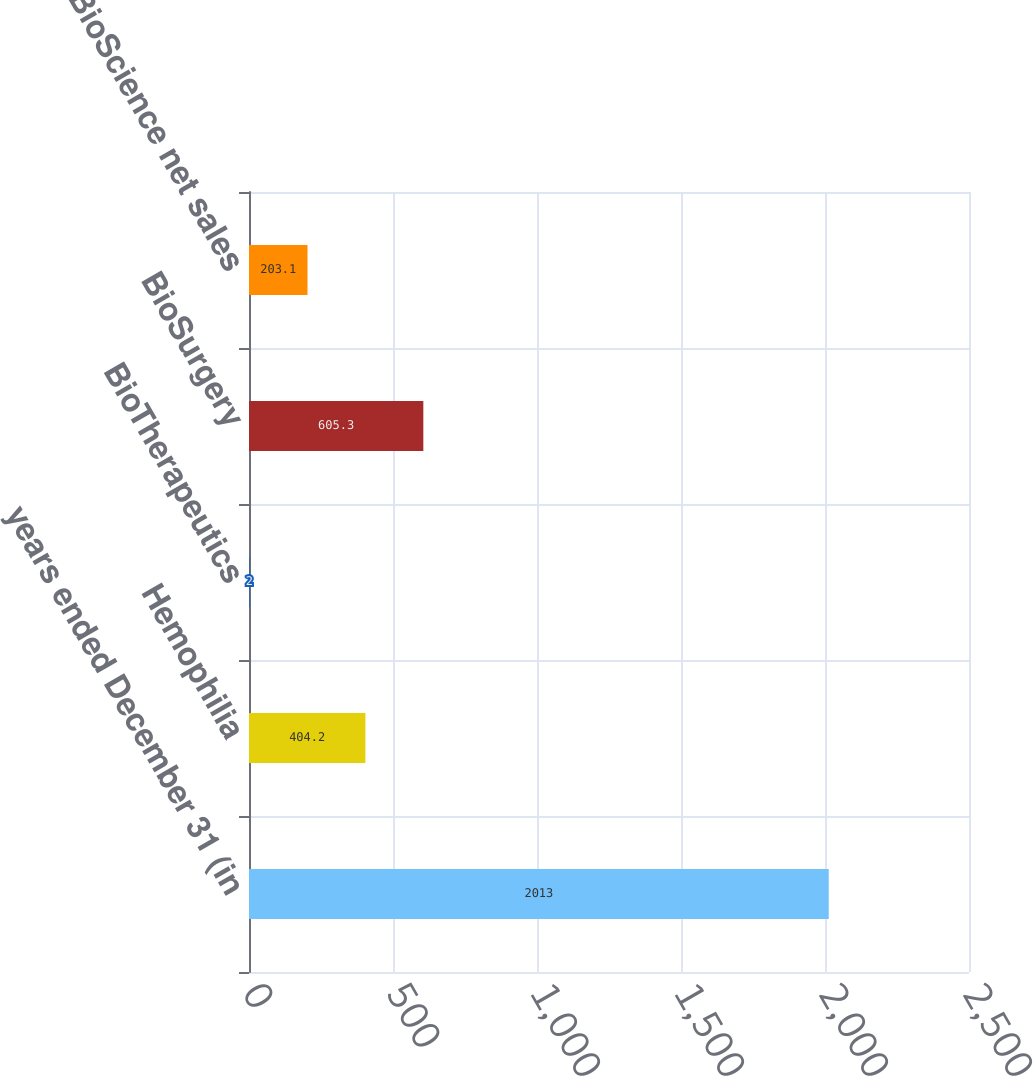Convert chart to OTSL. <chart><loc_0><loc_0><loc_500><loc_500><bar_chart><fcel>years ended December 31 (in<fcel>Hemophilia<fcel>BioTherapeutics<fcel>BioSurgery<fcel>Total BioScience net sales<nl><fcel>2013<fcel>404.2<fcel>2<fcel>605.3<fcel>203.1<nl></chart> 